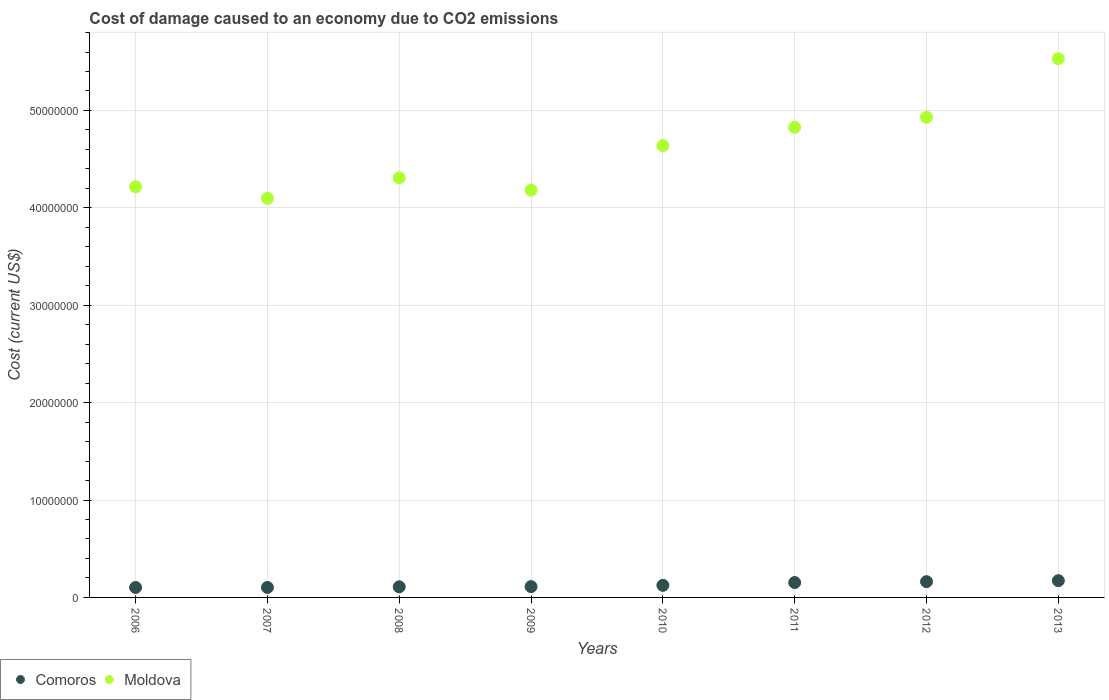How many different coloured dotlines are there?
Give a very brief answer. 2. What is the cost of damage caused due to CO2 emissisons in Comoros in 2009?
Ensure brevity in your answer.  1.11e+06. Across all years, what is the maximum cost of damage caused due to CO2 emissisons in Comoros?
Your answer should be compact. 1.72e+06. Across all years, what is the minimum cost of damage caused due to CO2 emissisons in Comoros?
Provide a short and direct response. 1.02e+06. In which year was the cost of damage caused due to CO2 emissisons in Moldova maximum?
Your answer should be very brief. 2013. In which year was the cost of damage caused due to CO2 emissisons in Comoros minimum?
Your answer should be compact. 2006. What is the total cost of damage caused due to CO2 emissisons in Comoros in the graph?
Your answer should be compact. 1.04e+07. What is the difference between the cost of damage caused due to CO2 emissisons in Moldova in 2007 and that in 2010?
Provide a succinct answer. -5.41e+06. What is the difference between the cost of damage caused due to CO2 emissisons in Moldova in 2006 and the cost of damage caused due to CO2 emissisons in Comoros in 2013?
Keep it short and to the point. 4.04e+07. What is the average cost of damage caused due to CO2 emissisons in Moldova per year?
Your response must be concise. 4.59e+07. In the year 2010, what is the difference between the cost of damage caused due to CO2 emissisons in Comoros and cost of damage caused due to CO2 emissisons in Moldova?
Your answer should be very brief. -4.51e+07. What is the ratio of the cost of damage caused due to CO2 emissisons in Comoros in 2008 to that in 2011?
Keep it short and to the point. 0.71. What is the difference between the highest and the second highest cost of damage caused due to CO2 emissisons in Comoros?
Ensure brevity in your answer.  9.95e+04. What is the difference between the highest and the lowest cost of damage caused due to CO2 emissisons in Moldova?
Make the answer very short. 1.43e+07. Is the cost of damage caused due to CO2 emissisons in Moldova strictly less than the cost of damage caused due to CO2 emissisons in Comoros over the years?
Your response must be concise. No. How many years are there in the graph?
Provide a succinct answer. 8. Are the values on the major ticks of Y-axis written in scientific E-notation?
Offer a terse response. No. Does the graph contain any zero values?
Make the answer very short. No. Where does the legend appear in the graph?
Make the answer very short. Bottom left. How many legend labels are there?
Provide a succinct answer. 2. What is the title of the graph?
Offer a terse response. Cost of damage caused to an economy due to CO2 emissions. Does "Congo (Democratic)" appear as one of the legend labels in the graph?
Provide a short and direct response. No. What is the label or title of the Y-axis?
Offer a terse response. Cost (current US$). What is the Cost (current US$) in Comoros in 2006?
Provide a short and direct response. 1.02e+06. What is the Cost (current US$) of Moldova in 2006?
Provide a short and direct response. 4.22e+07. What is the Cost (current US$) of Comoros in 2007?
Offer a terse response. 1.03e+06. What is the Cost (current US$) in Moldova in 2007?
Offer a terse response. 4.10e+07. What is the Cost (current US$) in Comoros in 2008?
Keep it short and to the point. 1.09e+06. What is the Cost (current US$) in Moldova in 2008?
Ensure brevity in your answer.  4.31e+07. What is the Cost (current US$) of Comoros in 2009?
Offer a terse response. 1.11e+06. What is the Cost (current US$) in Moldova in 2009?
Keep it short and to the point. 4.18e+07. What is the Cost (current US$) in Comoros in 2010?
Provide a succinct answer. 1.24e+06. What is the Cost (current US$) of Moldova in 2010?
Your answer should be very brief. 4.64e+07. What is the Cost (current US$) of Comoros in 2011?
Give a very brief answer. 1.53e+06. What is the Cost (current US$) in Moldova in 2011?
Offer a very short reply. 4.83e+07. What is the Cost (current US$) of Comoros in 2012?
Your answer should be very brief. 1.62e+06. What is the Cost (current US$) in Moldova in 2012?
Ensure brevity in your answer.  4.93e+07. What is the Cost (current US$) in Comoros in 2013?
Make the answer very short. 1.72e+06. What is the Cost (current US$) of Moldova in 2013?
Provide a succinct answer. 5.53e+07. Across all years, what is the maximum Cost (current US$) in Comoros?
Offer a very short reply. 1.72e+06. Across all years, what is the maximum Cost (current US$) in Moldova?
Your answer should be compact. 5.53e+07. Across all years, what is the minimum Cost (current US$) in Comoros?
Your answer should be compact. 1.02e+06. Across all years, what is the minimum Cost (current US$) of Moldova?
Your answer should be compact. 4.10e+07. What is the total Cost (current US$) in Comoros in the graph?
Keep it short and to the point. 1.04e+07. What is the total Cost (current US$) of Moldova in the graph?
Provide a short and direct response. 3.67e+08. What is the difference between the Cost (current US$) of Comoros in 2006 and that in 2007?
Offer a terse response. -6095.02. What is the difference between the Cost (current US$) in Moldova in 2006 and that in 2007?
Offer a very short reply. 1.18e+06. What is the difference between the Cost (current US$) of Comoros in 2006 and that in 2008?
Offer a very short reply. -7.04e+04. What is the difference between the Cost (current US$) in Moldova in 2006 and that in 2008?
Give a very brief answer. -9.19e+05. What is the difference between the Cost (current US$) in Comoros in 2006 and that in 2009?
Your answer should be compact. -9.02e+04. What is the difference between the Cost (current US$) of Moldova in 2006 and that in 2009?
Your response must be concise. 3.53e+05. What is the difference between the Cost (current US$) in Comoros in 2006 and that in 2010?
Your response must be concise. -2.19e+05. What is the difference between the Cost (current US$) in Moldova in 2006 and that in 2010?
Provide a succinct answer. -4.22e+06. What is the difference between the Cost (current US$) of Comoros in 2006 and that in 2011?
Give a very brief answer. -5.07e+05. What is the difference between the Cost (current US$) in Moldova in 2006 and that in 2011?
Offer a terse response. -6.10e+06. What is the difference between the Cost (current US$) in Comoros in 2006 and that in 2012?
Your response must be concise. -5.98e+05. What is the difference between the Cost (current US$) of Moldova in 2006 and that in 2012?
Your answer should be compact. -7.14e+06. What is the difference between the Cost (current US$) of Comoros in 2006 and that in 2013?
Your response must be concise. -6.97e+05. What is the difference between the Cost (current US$) of Moldova in 2006 and that in 2013?
Offer a terse response. -1.32e+07. What is the difference between the Cost (current US$) in Comoros in 2007 and that in 2008?
Offer a terse response. -6.43e+04. What is the difference between the Cost (current US$) in Moldova in 2007 and that in 2008?
Your answer should be compact. -2.10e+06. What is the difference between the Cost (current US$) in Comoros in 2007 and that in 2009?
Give a very brief answer. -8.41e+04. What is the difference between the Cost (current US$) of Moldova in 2007 and that in 2009?
Your answer should be compact. -8.32e+05. What is the difference between the Cost (current US$) in Comoros in 2007 and that in 2010?
Give a very brief answer. -2.13e+05. What is the difference between the Cost (current US$) in Moldova in 2007 and that in 2010?
Make the answer very short. -5.41e+06. What is the difference between the Cost (current US$) of Comoros in 2007 and that in 2011?
Offer a very short reply. -5.01e+05. What is the difference between the Cost (current US$) in Moldova in 2007 and that in 2011?
Offer a very short reply. -7.29e+06. What is the difference between the Cost (current US$) of Comoros in 2007 and that in 2012?
Ensure brevity in your answer.  -5.92e+05. What is the difference between the Cost (current US$) of Moldova in 2007 and that in 2012?
Keep it short and to the point. -8.32e+06. What is the difference between the Cost (current US$) of Comoros in 2007 and that in 2013?
Ensure brevity in your answer.  -6.91e+05. What is the difference between the Cost (current US$) of Moldova in 2007 and that in 2013?
Offer a very short reply. -1.43e+07. What is the difference between the Cost (current US$) of Comoros in 2008 and that in 2009?
Keep it short and to the point. -1.99e+04. What is the difference between the Cost (current US$) in Moldova in 2008 and that in 2009?
Provide a short and direct response. 1.27e+06. What is the difference between the Cost (current US$) in Comoros in 2008 and that in 2010?
Your answer should be compact. -1.49e+05. What is the difference between the Cost (current US$) in Moldova in 2008 and that in 2010?
Give a very brief answer. -3.30e+06. What is the difference between the Cost (current US$) in Comoros in 2008 and that in 2011?
Provide a short and direct response. -4.36e+05. What is the difference between the Cost (current US$) in Moldova in 2008 and that in 2011?
Your answer should be very brief. -5.18e+06. What is the difference between the Cost (current US$) of Comoros in 2008 and that in 2012?
Keep it short and to the point. -5.27e+05. What is the difference between the Cost (current US$) in Moldova in 2008 and that in 2012?
Provide a short and direct response. -6.22e+06. What is the difference between the Cost (current US$) of Comoros in 2008 and that in 2013?
Your answer should be very brief. -6.27e+05. What is the difference between the Cost (current US$) of Moldova in 2008 and that in 2013?
Offer a terse response. -1.22e+07. What is the difference between the Cost (current US$) of Comoros in 2009 and that in 2010?
Your response must be concise. -1.29e+05. What is the difference between the Cost (current US$) of Moldova in 2009 and that in 2010?
Offer a very short reply. -4.57e+06. What is the difference between the Cost (current US$) in Comoros in 2009 and that in 2011?
Make the answer very short. -4.17e+05. What is the difference between the Cost (current US$) in Moldova in 2009 and that in 2011?
Provide a succinct answer. -6.46e+06. What is the difference between the Cost (current US$) of Comoros in 2009 and that in 2012?
Offer a terse response. -5.08e+05. What is the difference between the Cost (current US$) of Moldova in 2009 and that in 2012?
Give a very brief answer. -7.49e+06. What is the difference between the Cost (current US$) in Comoros in 2009 and that in 2013?
Your answer should be very brief. -6.07e+05. What is the difference between the Cost (current US$) in Moldova in 2009 and that in 2013?
Provide a succinct answer. -1.35e+07. What is the difference between the Cost (current US$) in Comoros in 2010 and that in 2011?
Offer a terse response. -2.88e+05. What is the difference between the Cost (current US$) in Moldova in 2010 and that in 2011?
Provide a short and direct response. -1.88e+06. What is the difference between the Cost (current US$) of Comoros in 2010 and that in 2012?
Offer a very short reply. -3.79e+05. What is the difference between the Cost (current US$) in Moldova in 2010 and that in 2012?
Your answer should be very brief. -2.92e+06. What is the difference between the Cost (current US$) of Comoros in 2010 and that in 2013?
Offer a terse response. -4.78e+05. What is the difference between the Cost (current US$) in Moldova in 2010 and that in 2013?
Provide a short and direct response. -8.93e+06. What is the difference between the Cost (current US$) in Comoros in 2011 and that in 2012?
Your response must be concise. -9.10e+04. What is the difference between the Cost (current US$) of Moldova in 2011 and that in 2012?
Make the answer very short. -1.04e+06. What is the difference between the Cost (current US$) in Comoros in 2011 and that in 2013?
Offer a very short reply. -1.90e+05. What is the difference between the Cost (current US$) in Moldova in 2011 and that in 2013?
Offer a terse response. -7.05e+06. What is the difference between the Cost (current US$) of Comoros in 2012 and that in 2013?
Offer a terse response. -9.95e+04. What is the difference between the Cost (current US$) in Moldova in 2012 and that in 2013?
Provide a succinct answer. -6.01e+06. What is the difference between the Cost (current US$) in Comoros in 2006 and the Cost (current US$) in Moldova in 2007?
Your answer should be very brief. -4.00e+07. What is the difference between the Cost (current US$) in Comoros in 2006 and the Cost (current US$) in Moldova in 2008?
Offer a very short reply. -4.21e+07. What is the difference between the Cost (current US$) of Comoros in 2006 and the Cost (current US$) of Moldova in 2009?
Give a very brief answer. -4.08e+07. What is the difference between the Cost (current US$) in Comoros in 2006 and the Cost (current US$) in Moldova in 2010?
Offer a terse response. -4.54e+07. What is the difference between the Cost (current US$) of Comoros in 2006 and the Cost (current US$) of Moldova in 2011?
Your answer should be very brief. -4.72e+07. What is the difference between the Cost (current US$) in Comoros in 2006 and the Cost (current US$) in Moldova in 2012?
Offer a very short reply. -4.83e+07. What is the difference between the Cost (current US$) of Comoros in 2006 and the Cost (current US$) of Moldova in 2013?
Your response must be concise. -5.43e+07. What is the difference between the Cost (current US$) in Comoros in 2007 and the Cost (current US$) in Moldova in 2008?
Your answer should be very brief. -4.21e+07. What is the difference between the Cost (current US$) of Comoros in 2007 and the Cost (current US$) of Moldova in 2009?
Provide a succinct answer. -4.08e+07. What is the difference between the Cost (current US$) in Comoros in 2007 and the Cost (current US$) in Moldova in 2010?
Provide a short and direct response. -4.54e+07. What is the difference between the Cost (current US$) in Comoros in 2007 and the Cost (current US$) in Moldova in 2011?
Provide a short and direct response. -4.72e+07. What is the difference between the Cost (current US$) in Comoros in 2007 and the Cost (current US$) in Moldova in 2012?
Provide a short and direct response. -4.83e+07. What is the difference between the Cost (current US$) of Comoros in 2007 and the Cost (current US$) of Moldova in 2013?
Your answer should be compact. -5.43e+07. What is the difference between the Cost (current US$) in Comoros in 2008 and the Cost (current US$) in Moldova in 2009?
Provide a succinct answer. -4.07e+07. What is the difference between the Cost (current US$) of Comoros in 2008 and the Cost (current US$) of Moldova in 2010?
Provide a succinct answer. -4.53e+07. What is the difference between the Cost (current US$) of Comoros in 2008 and the Cost (current US$) of Moldova in 2011?
Your answer should be compact. -4.72e+07. What is the difference between the Cost (current US$) of Comoros in 2008 and the Cost (current US$) of Moldova in 2012?
Give a very brief answer. -4.82e+07. What is the difference between the Cost (current US$) of Comoros in 2008 and the Cost (current US$) of Moldova in 2013?
Ensure brevity in your answer.  -5.42e+07. What is the difference between the Cost (current US$) of Comoros in 2009 and the Cost (current US$) of Moldova in 2010?
Your answer should be very brief. -4.53e+07. What is the difference between the Cost (current US$) in Comoros in 2009 and the Cost (current US$) in Moldova in 2011?
Ensure brevity in your answer.  -4.72e+07. What is the difference between the Cost (current US$) of Comoros in 2009 and the Cost (current US$) of Moldova in 2012?
Provide a succinct answer. -4.82e+07. What is the difference between the Cost (current US$) in Comoros in 2009 and the Cost (current US$) in Moldova in 2013?
Offer a terse response. -5.42e+07. What is the difference between the Cost (current US$) in Comoros in 2010 and the Cost (current US$) in Moldova in 2011?
Give a very brief answer. -4.70e+07. What is the difference between the Cost (current US$) in Comoros in 2010 and the Cost (current US$) in Moldova in 2012?
Your response must be concise. -4.81e+07. What is the difference between the Cost (current US$) of Comoros in 2010 and the Cost (current US$) of Moldova in 2013?
Your answer should be compact. -5.41e+07. What is the difference between the Cost (current US$) in Comoros in 2011 and the Cost (current US$) in Moldova in 2012?
Keep it short and to the point. -4.78e+07. What is the difference between the Cost (current US$) of Comoros in 2011 and the Cost (current US$) of Moldova in 2013?
Offer a very short reply. -5.38e+07. What is the difference between the Cost (current US$) in Comoros in 2012 and the Cost (current US$) in Moldova in 2013?
Offer a terse response. -5.37e+07. What is the average Cost (current US$) in Comoros per year?
Offer a terse response. 1.30e+06. What is the average Cost (current US$) of Moldova per year?
Your response must be concise. 4.59e+07. In the year 2006, what is the difference between the Cost (current US$) of Comoros and Cost (current US$) of Moldova?
Keep it short and to the point. -4.11e+07. In the year 2007, what is the difference between the Cost (current US$) of Comoros and Cost (current US$) of Moldova?
Your answer should be very brief. -4.00e+07. In the year 2008, what is the difference between the Cost (current US$) in Comoros and Cost (current US$) in Moldova?
Offer a very short reply. -4.20e+07. In the year 2009, what is the difference between the Cost (current US$) in Comoros and Cost (current US$) in Moldova?
Provide a succinct answer. -4.07e+07. In the year 2010, what is the difference between the Cost (current US$) of Comoros and Cost (current US$) of Moldova?
Your answer should be compact. -4.51e+07. In the year 2011, what is the difference between the Cost (current US$) in Comoros and Cost (current US$) in Moldova?
Ensure brevity in your answer.  -4.67e+07. In the year 2012, what is the difference between the Cost (current US$) of Comoros and Cost (current US$) of Moldova?
Offer a terse response. -4.77e+07. In the year 2013, what is the difference between the Cost (current US$) of Comoros and Cost (current US$) of Moldova?
Provide a short and direct response. -5.36e+07. What is the ratio of the Cost (current US$) of Moldova in 2006 to that in 2007?
Provide a succinct answer. 1.03. What is the ratio of the Cost (current US$) in Comoros in 2006 to that in 2008?
Offer a terse response. 0.94. What is the ratio of the Cost (current US$) in Moldova in 2006 to that in 2008?
Offer a terse response. 0.98. What is the ratio of the Cost (current US$) in Comoros in 2006 to that in 2009?
Ensure brevity in your answer.  0.92. What is the ratio of the Cost (current US$) of Moldova in 2006 to that in 2009?
Ensure brevity in your answer.  1.01. What is the ratio of the Cost (current US$) of Comoros in 2006 to that in 2010?
Ensure brevity in your answer.  0.82. What is the ratio of the Cost (current US$) of Moldova in 2006 to that in 2010?
Ensure brevity in your answer.  0.91. What is the ratio of the Cost (current US$) of Comoros in 2006 to that in 2011?
Provide a succinct answer. 0.67. What is the ratio of the Cost (current US$) in Moldova in 2006 to that in 2011?
Your answer should be very brief. 0.87. What is the ratio of the Cost (current US$) in Comoros in 2006 to that in 2012?
Provide a short and direct response. 0.63. What is the ratio of the Cost (current US$) in Moldova in 2006 to that in 2012?
Offer a very short reply. 0.86. What is the ratio of the Cost (current US$) in Comoros in 2006 to that in 2013?
Your answer should be very brief. 0.59. What is the ratio of the Cost (current US$) of Moldova in 2006 to that in 2013?
Offer a terse response. 0.76. What is the ratio of the Cost (current US$) in Comoros in 2007 to that in 2008?
Offer a very short reply. 0.94. What is the ratio of the Cost (current US$) in Moldova in 2007 to that in 2008?
Your answer should be compact. 0.95. What is the ratio of the Cost (current US$) of Comoros in 2007 to that in 2009?
Your answer should be very brief. 0.92. What is the ratio of the Cost (current US$) in Moldova in 2007 to that in 2009?
Ensure brevity in your answer.  0.98. What is the ratio of the Cost (current US$) in Comoros in 2007 to that in 2010?
Your answer should be compact. 0.83. What is the ratio of the Cost (current US$) in Moldova in 2007 to that in 2010?
Ensure brevity in your answer.  0.88. What is the ratio of the Cost (current US$) in Comoros in 2007 to that in 2011?
Ensure brevity in your answer.  0.67. What is the ratio of the Cost (current US$) of Moldova in 2007 to that in 2011?
Give a very brief answer. 0.85. What is the ratio of the Cost (current US$) in Comoros in 2007 to that in 2012?
Make the answer very short. 0.63. What is the ratio of the Cost (current US$) in Moldova in 2007 to that in 2012?
Provide a succinct answer. 0.83. What is the ratio of the Cost (current US$) in Comoros in 2007 to that in 2013?
Your answer should be very brief. 0.6. What is the ratio of the Cost (current US$) in Moldova in 2007 to that in 2013?
Offer a very short reply. 0.74. What is the ratio of the Cost (current US$) of Comoros in 2008 to that in 2009?
Your response must be concise. 0.98. What is the ratio of the Cost (current US$) of Moldova in 2008 to that in 2009?
Offer a terse response. 1.03. What is the ratio of the Cost (current US$) of Comoros in 2008 to that in 2010?
Offer a very short reply. 0.88. What is the ratio of the Cost (current US$) of Moldova in 2008 to that in 2010?
Provide a succinct answer. 0.93. What is the ratio of the Cost (current US$) of Comoros in 2008 to that in 2011?
Your response must be concise. 0.71. What is the ratio of the Cost (current US$) of Moldova in 2008 to that in 2011?
Offer a very short reply. 0.89. What is the ratio of the Cost (current US$) in Comoros in 2008 to that in 2012?
Offer a terse response. 0.67. What is the ratio of the Cost (current US$) in Moldova in 2008 to that in 2012?
Your answer should be very brief. 0.87. What is the ratio of the Cost (current US$) of Comoros in 2008 to that in 2013?
Ensure brevity in your answer.  0.64. What is the ratio of the Cost (current US$) in Moldova in 2008 to that in 2013?
Your answer should be compact. 0.78. What is the ratio of the Cost (current US$) of Comoros in 2009 to that in 2010?
Offer a very short reply. 0.9. What is the ratio of the Cost (current US$) of Moldova in 2009 to that in 2010?
Your answer should be compact. 0.9. What is the ratio of the Cost (current US$) of Comoros in 2009 to that in 2011?
Offer a terse response. 0.73. What is the ratio of the Cost (current US$) in Moldova in 2009 to that in 2011?
Ensure brevity in your answer.  0.87. What is the ratio of the Cost (current US$) in Comoros in 2009 to that in 2012?
Offer a terse response. 0.69. What is the ratio of the Cost (current US$) of Moldova in 2009 to that in 2012?
Your answer should be very brief. 0.85. What is the ratio of the Cost (current US$) of Comoros in 2009 to that in 2013?
Keep it short and to the point. 0.65. What is the ratio of the Cost (current US$) in Moldova in 2009 to that in 2013?
Offer a terse response. 0.76. What is the ratio of the Cost (current US$) in Comoros in 2010 to that in 2011?
Your answer should be compact. 0.81. What is the ratio of the Cost (current US$) of Moldova in 2010 to that in 2011?
Your answer should be very brief. 0.96. What is the ratio of the Cost (current US$) in Comoros in 2010 to that in 2012?
Keep it short and to the point. 0.77. What is the ratio of the Cost (current US$) in Moldova in 2010 to that in 2012?
Make the answer very short. 0.94. What is the ratio of the Cost (current US$) in Comoros in 2010 to that in 2013?
Provide a succinct answer. 0.72. What is the ratio of the Cost (current US$) of Moldova in 2010 to that in 2013?
Give a very brief answer. 0.84. What is the ratio of the Cost (current US$) in Comoros in 2011 to that in 2012?
Your answer should be very brief. 0.94. What is the ratio of the Cost (current US$) of Moldova in 2011 to that in 2012?
Offer a very short reply. 0.98. What is the ratio of the Cost (current US$) in Comoros in 2011 to that in 2013?
Your answer should be very brief. 0.89. What is the ratio of the Cost (current US$) in Moldova in 2011 to that in 2013?
Offer a very short reply. 0.87. What is the ratio of the Cost (current US$) of Comoros in 2012 to that in 2013?
Keep it short and to the point. 0.94. What is the ratio of the Cost (current US$) of Moldova in 2012 to that in 2013?
Keep it short and to the point. 0.89. What is the difference between the highest and the second highest Cost (current US$) of Comoros?
Your answer should be very brief. 9.95e+04. What is the difference between the highest and the second highest Cost (current US$) in Moldova?
Your answer should be compact. 6.01e+06. What is the difference between the highest and the lowest Cost (current US$) in Comoros?
Provide a succinct answer. 6.97e+05. What is the difference between the highest and the lowest Cost (current US$) in Moldova?
Make the answer very short. 1.43e+07. 